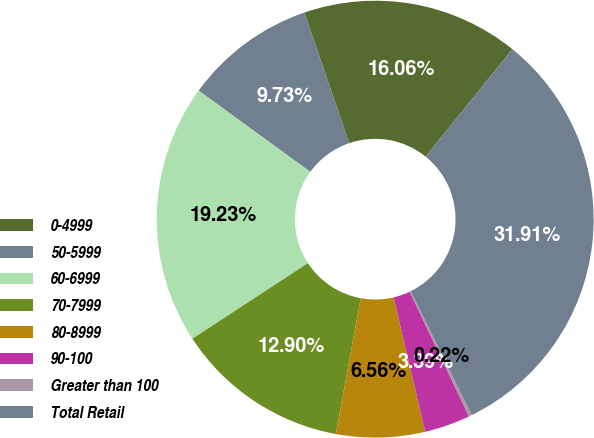Convert chart. <chart><loc_0><loc_0><loc_500><loc_500><pie_chart><fcel>0-4999<fcel>50-5999<fcel>60-6999<fcel>70-7999<fcel>80-8999<fcel>90-100<fcel>Greater than 100<fcel>Total Retail<nl><fcel>16.06%<fcel>9.73%<fcel>19.23%<fcel>12.9%<fcel>6.56%<fcel>3.39%<fcel>0.22%<fcel>31.91%<nl></chart> 